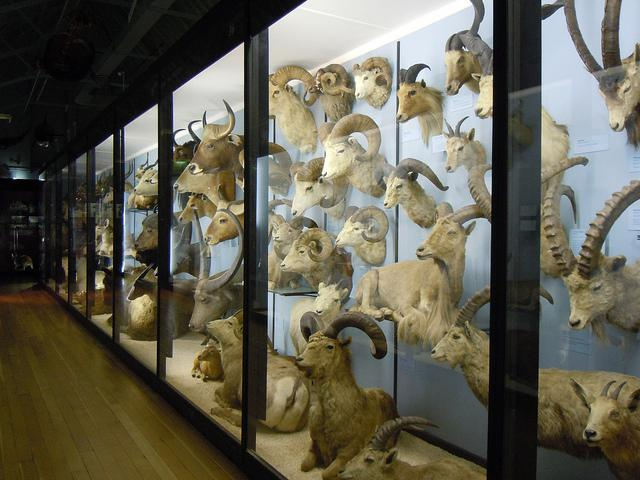What form of art was used to preserve these dead animals? Please explain your reasoning. taxidermy. These are stuffed dead animals which is called taxidermy. 